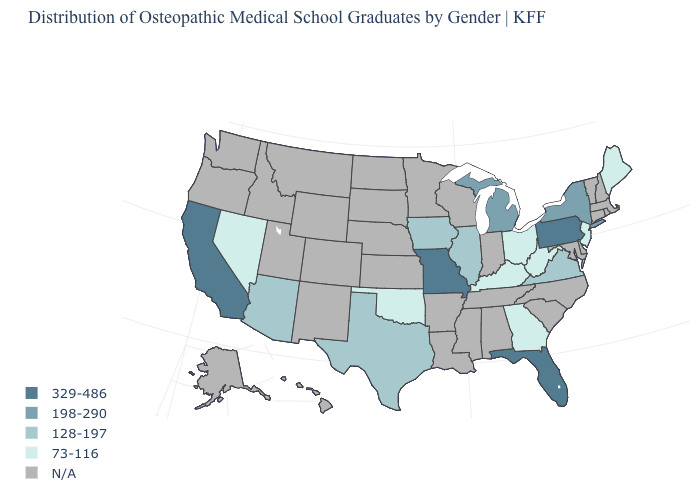What is the highest value in the West ?
Answer briefly. 329-486. What is the value of Vermont?
Answer briefly. N/A. What is the value of Idaho?
Short answer required. N/A. Which states hav the highest value in the West?
Write a very short answer. California. Name the states that have a value in the range 329-486?
Short answer required. California, Florida, Missouri, Pennsylvania. What is the value of New York?
Answer briefly. 198-290. What is the highest value in the West ?
Give a very brief answer. 329-486. Does Ohio have the lowest value in the USA?
Be succinct. Yes. Which states have the lowest value in the Northeast?
Quick response, please. Maine, New Jersey. Does the map have missing data?
Answer briefly. Yes. Name the states that have a value in the range 198-290?
Write a very short answer. Michigan, New York. What is the value of Washington?
Quick response, please. N/A. 